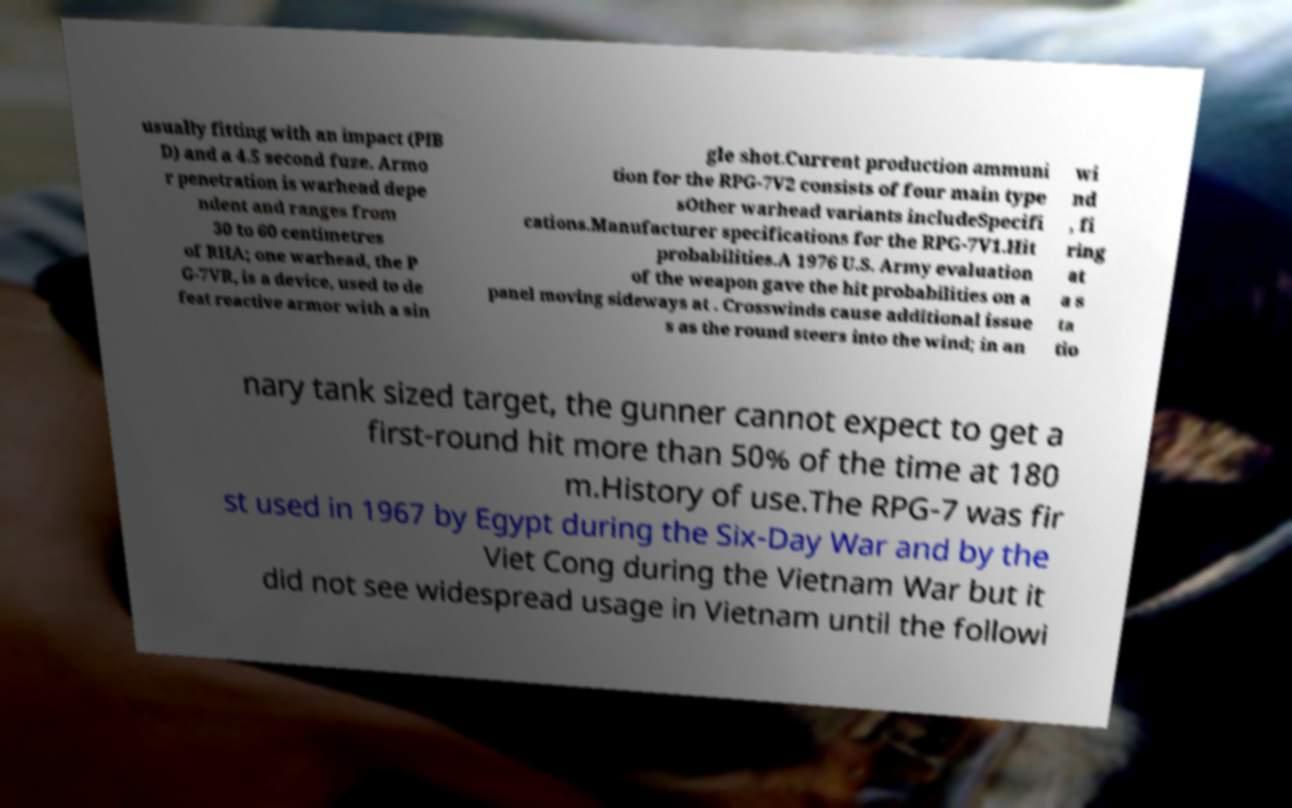Please read and relay the text visible in this image. What does it say? usually fitting with an impact (PIB D) and a 4.5 second fuze. Armo r penetration is warhead depe ndent and ranges from 30 to 60 centimetres of RHA; one warhead, the P G-7VR, is a device, used to de feat reactive armor with a sin gle shot.Current production ammuni tion for the RPG-7V2 consists of four main type sOther warhead variants includeSpecifi cations.Manufacturer specifications for the RPG-7V1.Hit probabilities.A 1976 U.S. Army evaluation of the weapon gave the hit probabilities on a panel moving sideways at . Crosswinds cause additional issue s as the round steers into the wind; in an wi nd , fi ring at a s ta tio nary tank sized target, the gunner cannot expect to get a first-round hit more than 50% of the time at 180 m.History of use.The RPG-7 was fir st used in 1967 by Egypt during the Six-Day War and by the Viet Cong during the Vietnam War but it did not see widespread usage in Vietnam until the followi 